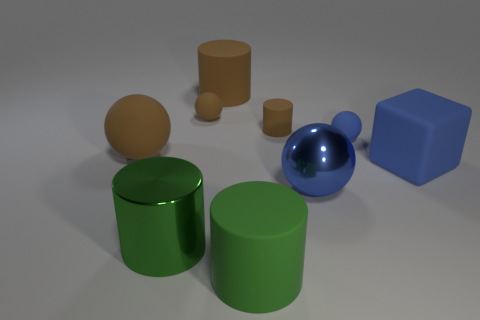The rubber block that is the same color as the big metallic sphere is what size?
Give a very brief answer. Large. There is a brown rubber object right of the large brown rubber cylinder; what number of small matte things are on the left side of it?
Your answer should be very brief. 1. What is the material of the big object that is the same color as the big rubber sphere?
Make the answer very short. Rubber. What number of other things are the same color as the small cylinder?
Your answer should be compact. 3. There is a ball behind the blue rubber thing left of the rubber block; what color is it?
Give a very brief answer. Brown. Is there another cylinder that has the same color as the large metallic cylinder?
Your answer should be compact. Yes. What number of matte things are either green cylinders or tiny green cylinders?
Offer a very short reply. 1. Is there a tiny object that has the same material as the big blue ball?
Your answer should be very brief. No. How many large matte things are both behind the green shiny thing and to the left of the large blue rubber thing?
Your response must be concise. 2. Are there fewer big blue rubber blocks that are in front of the big metal sphere than tiny brown things that are behind the tiny brown matte cylinder?
Provide a short and direct response. Yes. 